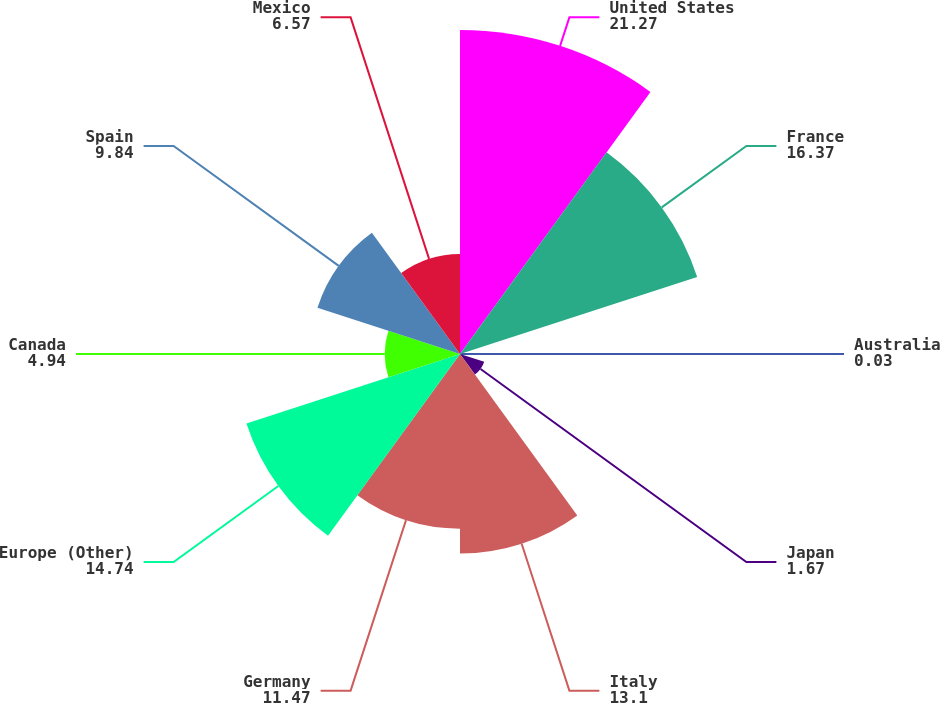Convert chart to OTSL. <chart><loc_0><loc_0><loc_500><loc_500><pie_chart><fcel>United States<fcel>France<fcel>Australia<fcel>Japan<fcel>Italy<fcel>Germany<fcel>Europe (Other)<fcel>Canada<fcel>Spain<fcel>Mexico<nl><fcel>21.27%<fcel>16.37%<fcel>0.03%<fcel>1.67%<fcel>13.1%<fcel>11.47%<fcel>14.74%<fcel>4.94%<fcel>9.84%<fcel>6.57%<nl></chart> 